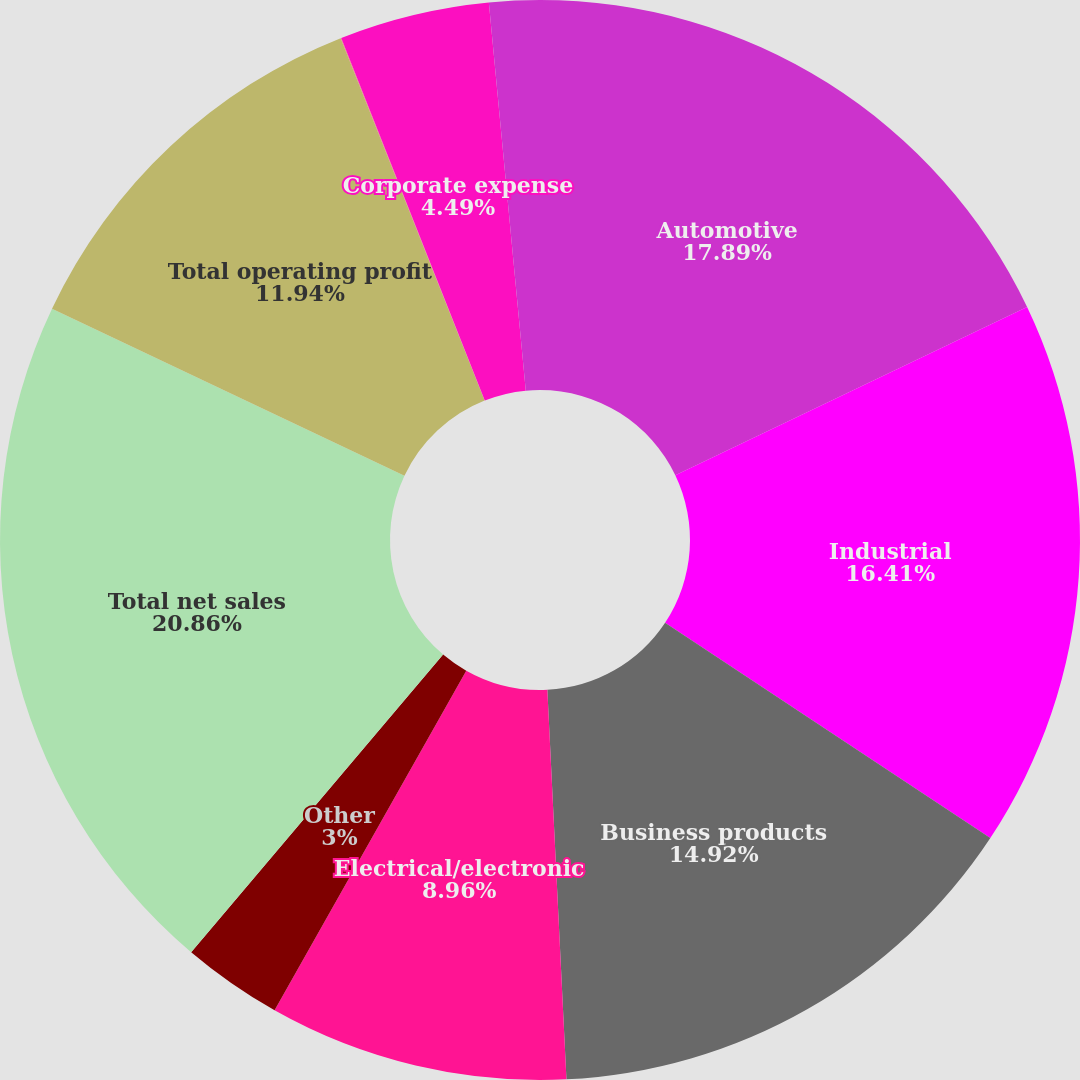<chart> <loc_0><loc_0><loc_500><loc_500><pie_chart><fcel>Automotive<fcel>Industrial<fcel>Business products<fcel>Electrical/electronic<fcel>Other<fcel>Total net sales<fcel>Total operating profit<fcel>Interest expense net<fcel>Corporate expense<fcel>Intangible asset amortization<nl><fcel>17.9%<fcel>16.41%<fcel>14.92%<fcel>8.96%<fcel>3.0%<fcel>20.87%<fcel>11.94%<fcel>0.02%<fcel>4.49%<fcel>1.51%<nl></chart> 